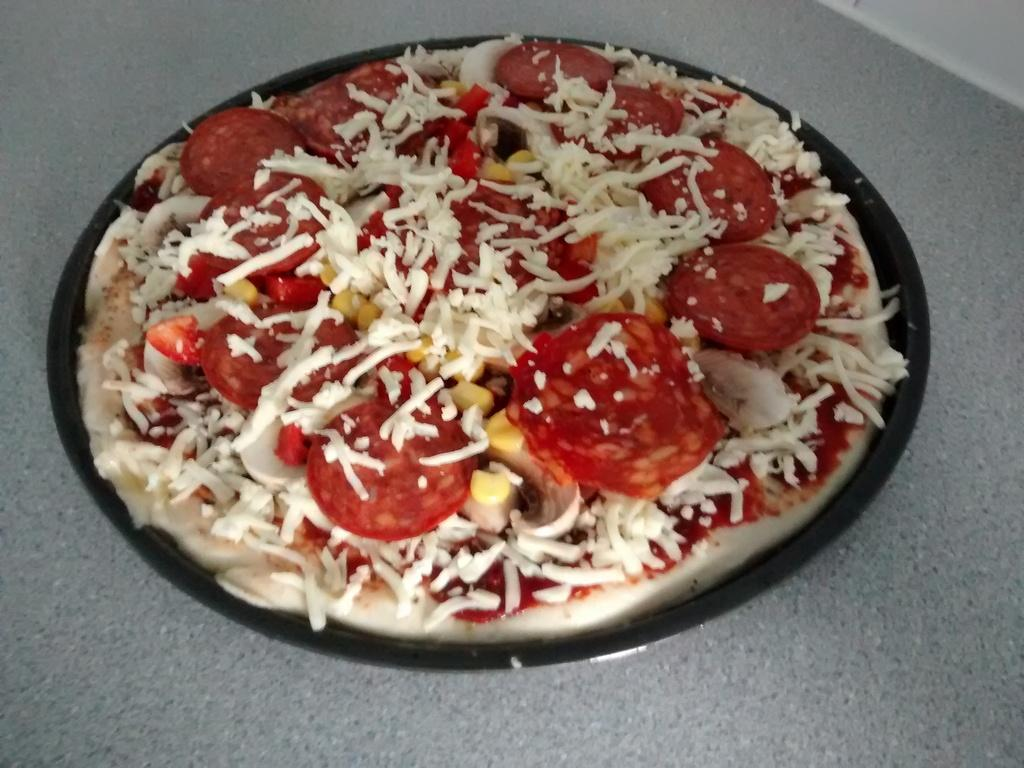What type of food is visible on the platter in the image? There is a platter of pizza in the image. Can you describe the surface on which the platter of pizza is placed? The platter of pizza is placed on a surface of an object. What news headline can be seen on the pizza in the image? There are no news headlines present on the pizza in the image. 